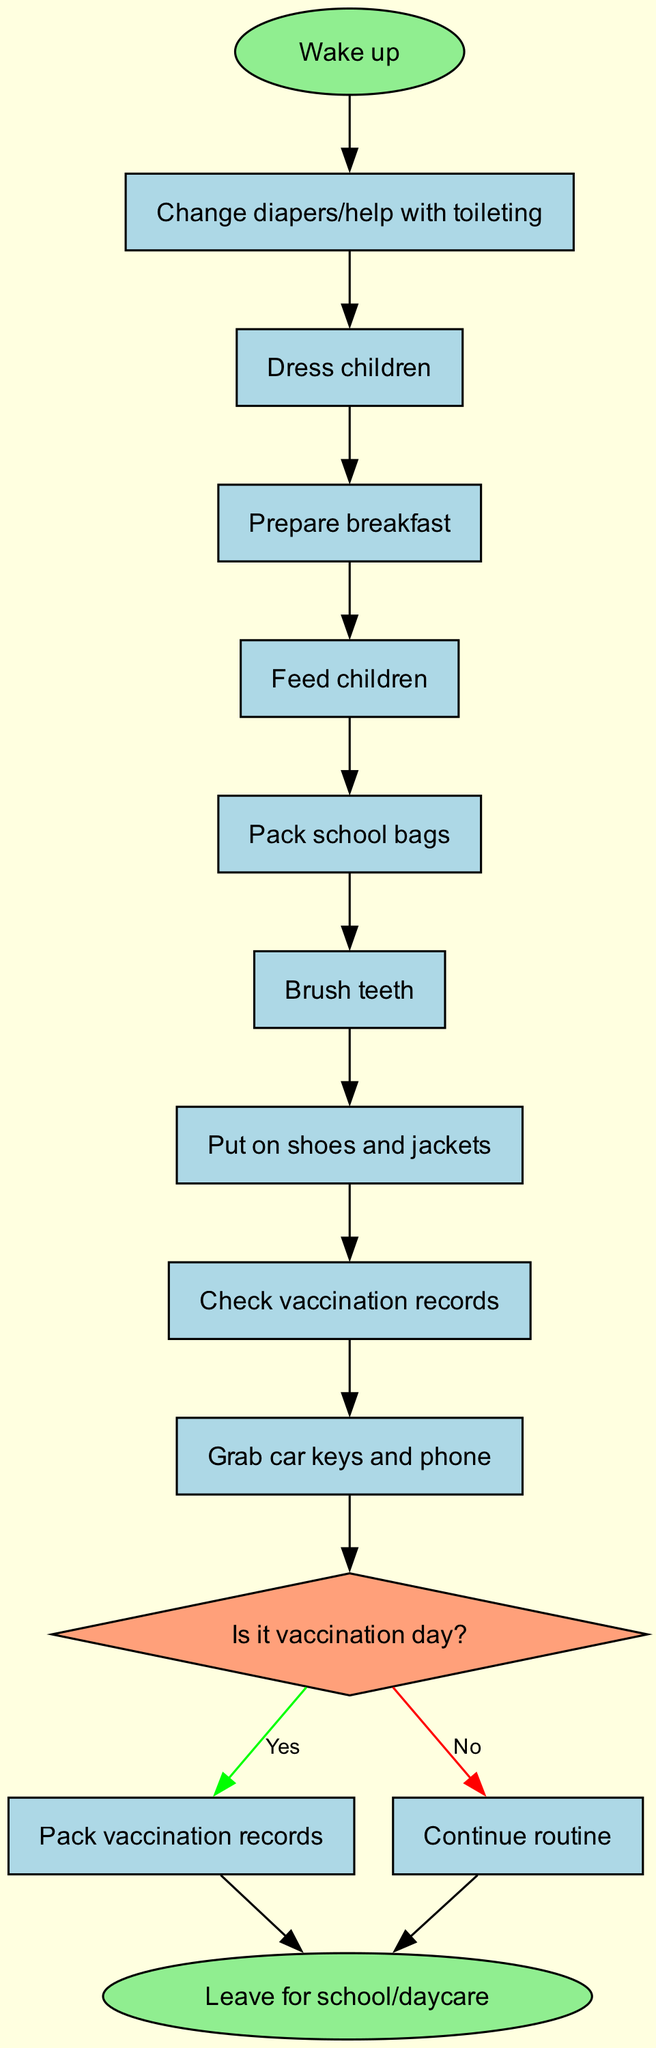What is the first task after waking up? The diagram starts with the "Wake up" node, which leads directly to the first task. The first task listed under nodes is "Change diapers/help with toileting."
Answer: Change diapers/help with toileting How many tasks are there in total? The diagram lists a set of nodes, where each represents a task to be completed. There are 8 tasks listed in the nodes.
Answer: 8 What happens if it is vaccination day? According to the decision node "Is it vaccination day?", if the answer is "Yes," then the next step is to "Pack vaccination records," which is a specific task.
Answer: Pack vaccination records What is the last task performed before leaving for school/daycare? After completing all tasks and any necessary decision paths, the final action leading to the end of the flowchart is to "Leave for school/daycare." This is the ultimate task performed.
Answer: Leave for school/daycare Which task immediately follows the "Brush teeth" task? In the sequence of tasks shown in the diagram, after "Brush teeth," the next task that follows is "Put on shoes and jackets."
Answer: Put on shoes and jackets What shape represents the decision node? The diagram indicates decision nodes as diamonds, specifically stating this in the diagram's node shape description, where "Is it vaccination day?" is the only decision node.
Answer: Diamond If the answer to the decision "Is it vaccination day?" is no, what is the next step? If the answer is "No," the flowchart indicates to "Continue routine," which proceeds to the end of the flow. This remains within the loop of tasks without adding any new task.
Answer: Continue routine How many edges connect the tasks in the diagram? The diagram has edges connecting the tasks sequentially. Since there are 8 tasks, they are connected by 7 edges (connecting each task to the next one). The decision edges add a few more, but based purely on task connections, there are 7.
Answer: 7 What color is the start node? The start node, labeled "Wake up," is represented in a specific color in the diagram. It is colored light green as per the style set for the start node in the diagram.
Answer: Light green 